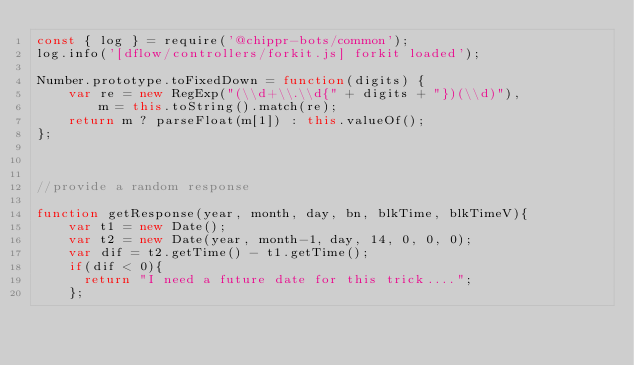Convert code to text. <code><loc_0><loc_0><loc_500><loc_500><_JavaScript_>const { log } = require('@chippr-bots/common');
log.info('[dflow/controllers/forkit.js] forkit loaded');

Number.prototype.toFixedDown = function(digits) {
    var re = new RegExp("(\\d+\\.\\d{" + digits + "})(\\d)"),
        m = this.toString().match(re);
    return m ? parseFloat(m[1]) : this.valueOf();
};



//provide a random response

function getResponse(year, month, day, bn, blkTime, blkTimeV){
    var t1 = new Date();
    var t2 = new Date(year, month-1, day, 14, 0, 0, 0);
    var dif = t2.getTime() - t1.getTime();
    if(dif < 0){
      return "I need a future date for this trick....";
    };</code> 